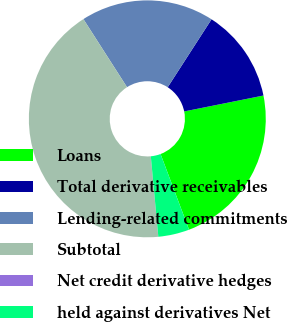Convert chart to OTSL. <chart><loc_0><loc_0><loc_500><loc_500><pie_chart><fcel>Loans<fcel>Total derivative receivables<fcel>Lending-related commitments<fcel>Subtotal<fcel>Net credit derivative hedges<fcel>held against derivatives Net<nl><fcel>22.42%<fcel>12.73%<fcel>18.19%<fcel>42.4%<fcel>0.01%<fcel>4.25%<nl></chart> 